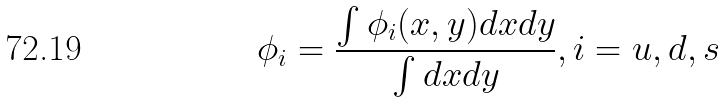<formula> <loc_0><loc_0><loc_500><loc_500>\phi _ { i } = \frac { \int \phi _ { i } ( x , y ) d x d y } { \int d x d y } , i = u , d , s</formula> 